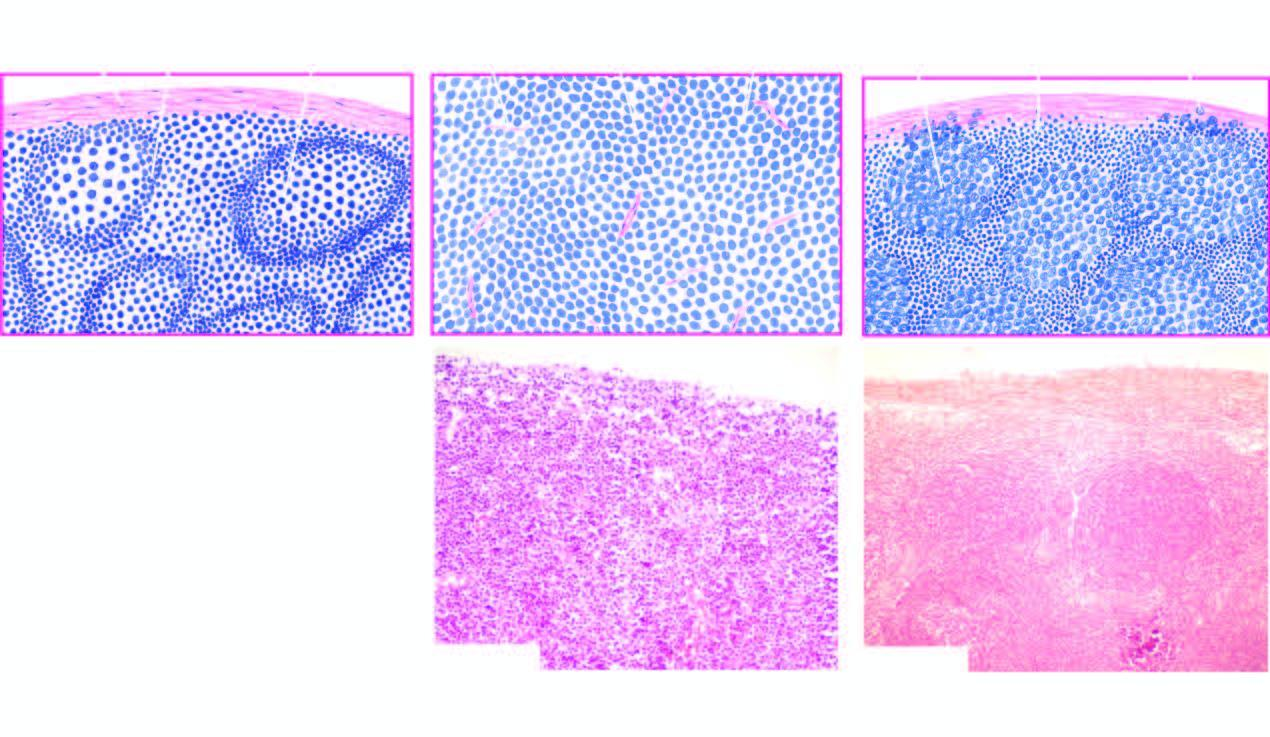what is follicular lymphoma contrasted with?
Answer the question using a single word or phrase. Structure of normal lymph node a 